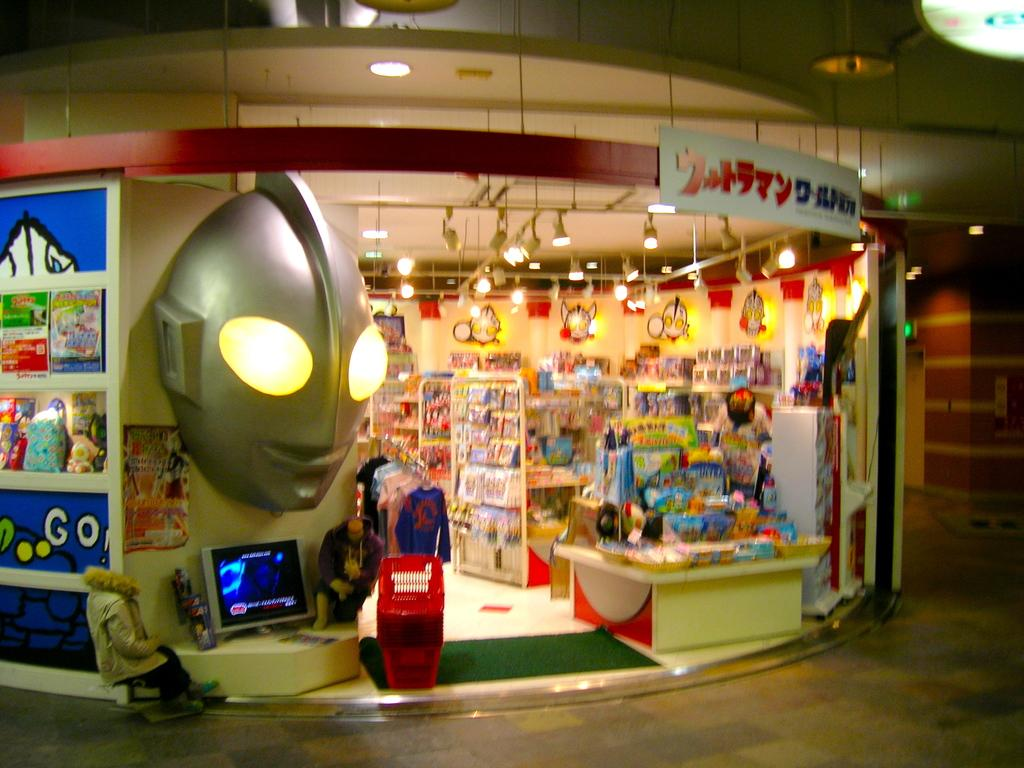<image>
Render a clear and concise summary of the photo. A Japanese shop with the English word Go! written on the sign outside. 